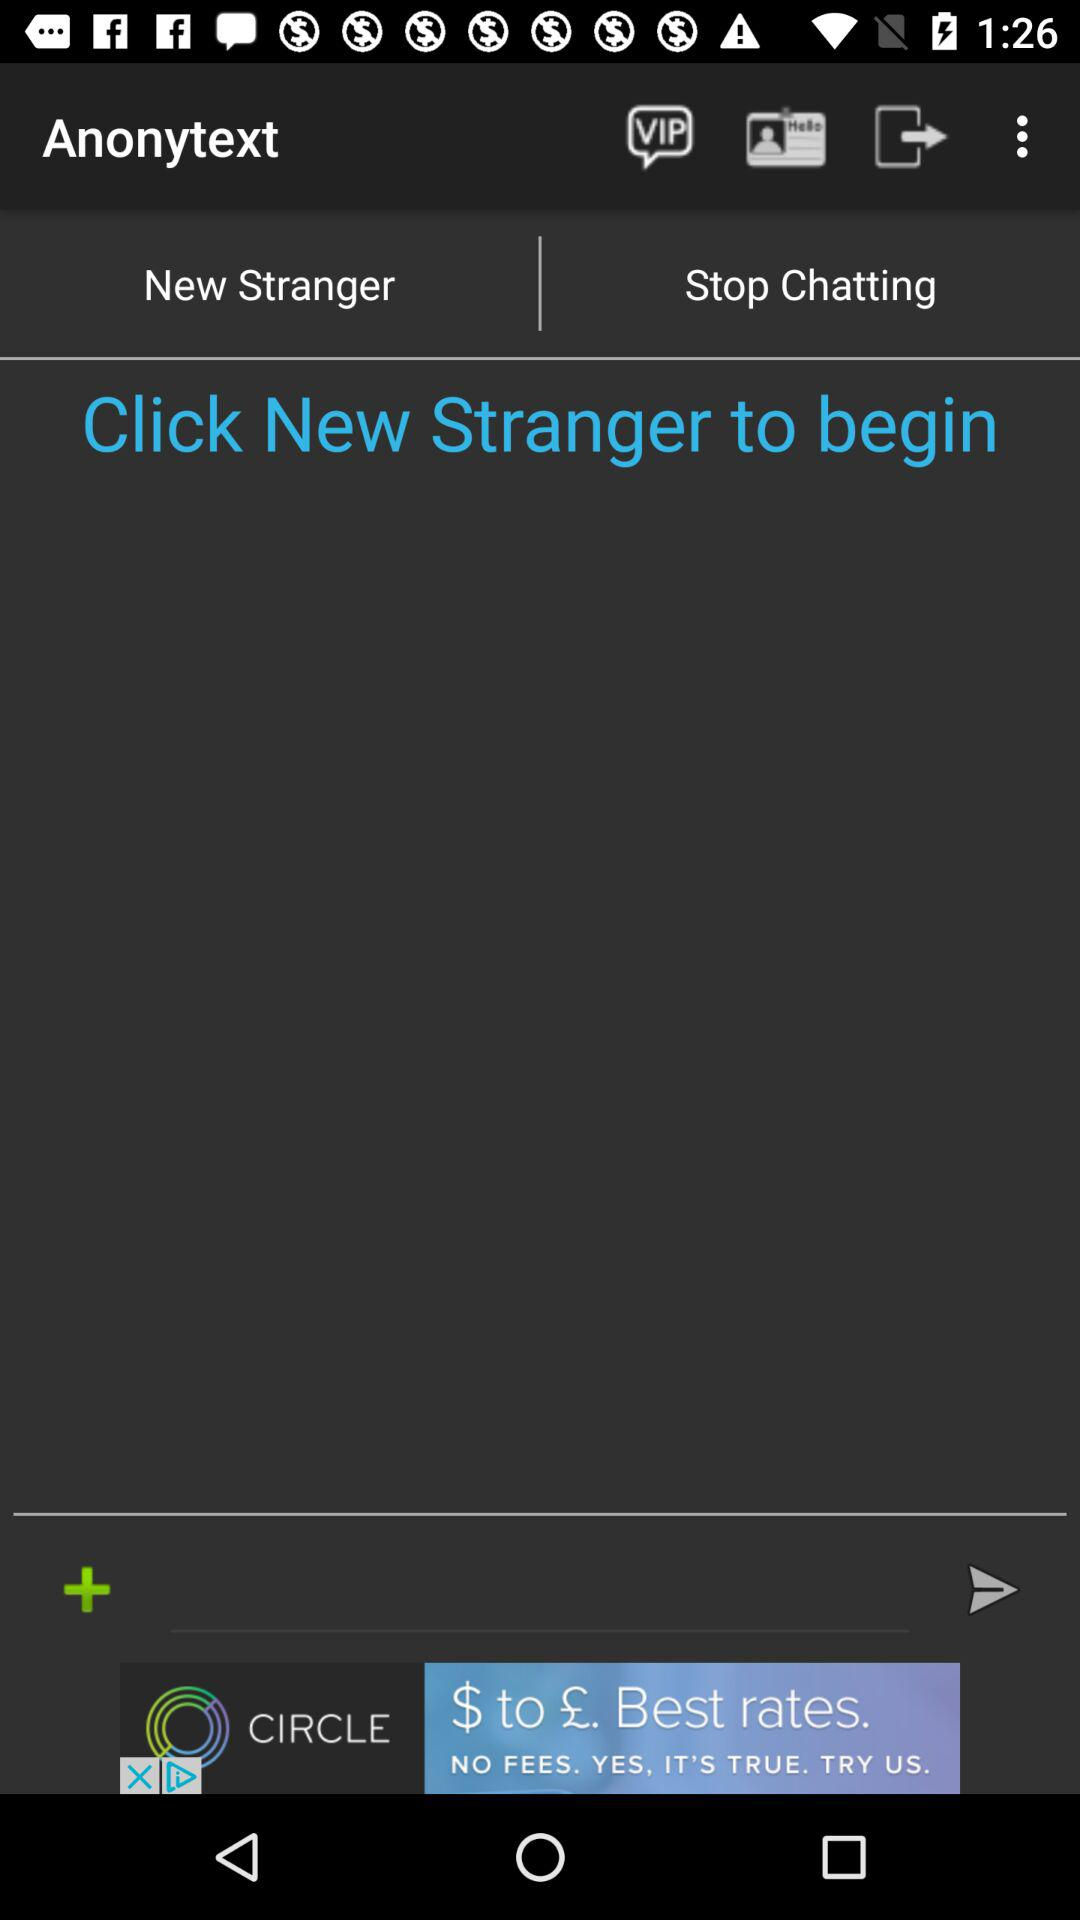What is the name of the application? The name of the application is "Anonytext". 